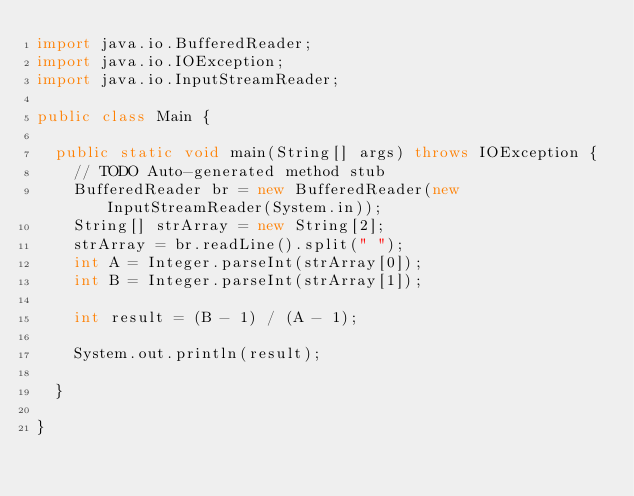<code> <loc_0><loc_0><loc_500><loc_500><_Java_>import java.io.BufferedReader;
import java.io.IOException;
import java.io.InputStreamReader;

public class Main {

	public static void main(String[] args) throws IOException {
		// TODO Auto-generated method stub
		BufferedReader br = new BufferedReader(new InputStreamReader(System.in));
		String[] strArray = new String[2];
		strArray = br.readLine().split(" ");
		int A = Integer.parseInt(strArray[0]);
		int B = Integer.parseInt(strArray[1]);

		int result = (B - 1) / (A - 1);

		System.out.println(result);

	}

}
</code> 